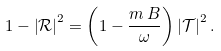<formula> <loc_0><loc_0><loc_500><loc_500>1 - \left | \mathcal { R } \right | ^ { 2 } = \left ( 1 - \frac { m \, B } { \omega } \right ) \left | \mathcal { T } \right | ^ { 2 } .</formula> 